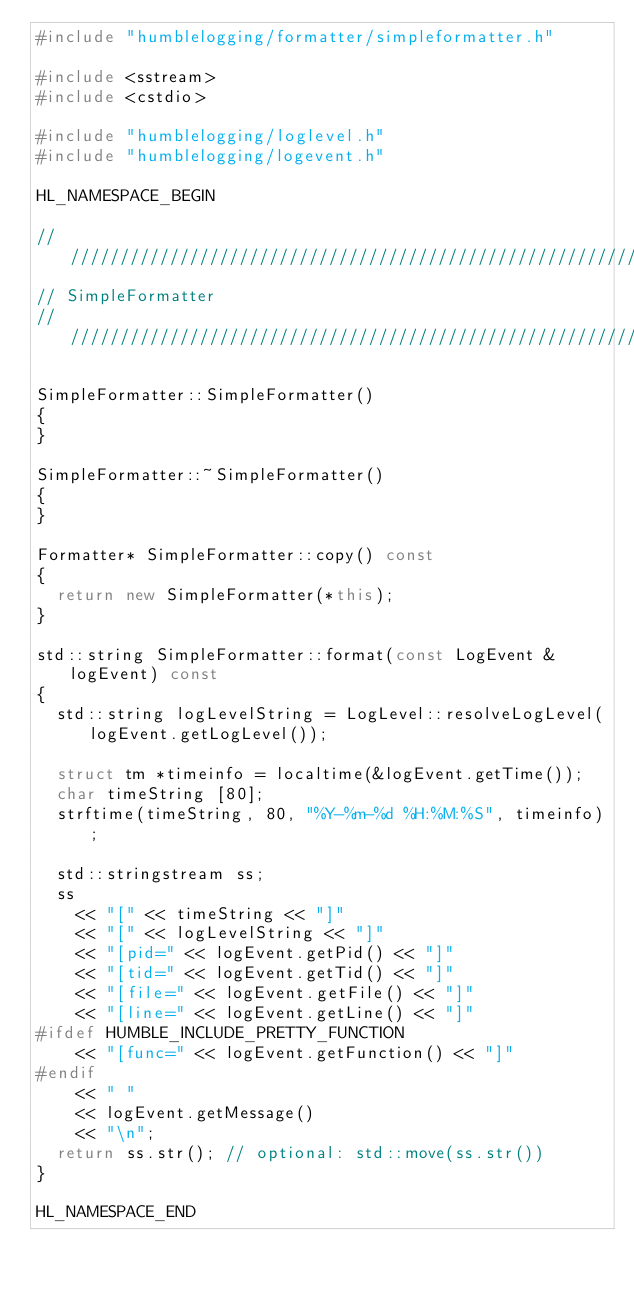<code> <loc_0><loc_0><loc_500><loc_500><_C++_>#include "humblelogging/formatter/simpleformatter.h"

#include <sstream>
#include <cstdio>

#include "humblelogging/loglevel.h"
#include "humblelogging/logevent.h"

HL_NAMESPACE_BEGIN

///////////////////////////////////////////////////////////////////////////////
// SimpleFormatter
///////////////////////////////////////////////////////////////////////////////

SimpleFormatter::SimpleFormatter()
{
}

SimpleFormatter::~SimpleFormatter()
{
}

Formatter* SimpleFormatter::copy() const
{
  return new SimpleFormatter(*this);
}

std::string SimpleFormatter::format(const LogEvent &logEvent) const
{
  std::string logLevelString = LogLevel::resolveLogLevel(logEvent.getLogLevel());

  struct tm *timeinfo = localtime(&logEvent.getTime());
  char timeString [80];
  strftime(timeString, 80, "%Y-%m-%d %H:%M:%S", timeinfo);

  std::stringstream ss;
  ss
    << "[" << timeString << "]"
    << "[" << logLevelString << "]"
    << "[pid=" << logEvent.getPid() << "]"
    << "[tid=" << logEvent.getTid() << "]"
    << "[file=" << logEvent.getFile() << "]"
    << "[line=" << logEvent.getLine() << "]"
#ifdef HUMBLE_INCLUDE_PRETTY_FUNCTION
    << "[func=" << logEvent.getFunction() << "]"
#endif
    << " "
    << logEvent.getMessage()
    << "\n";
  return ss.str(); // optional: std::move(ss.str())
}

HL_NAMESPACE_END</code> 